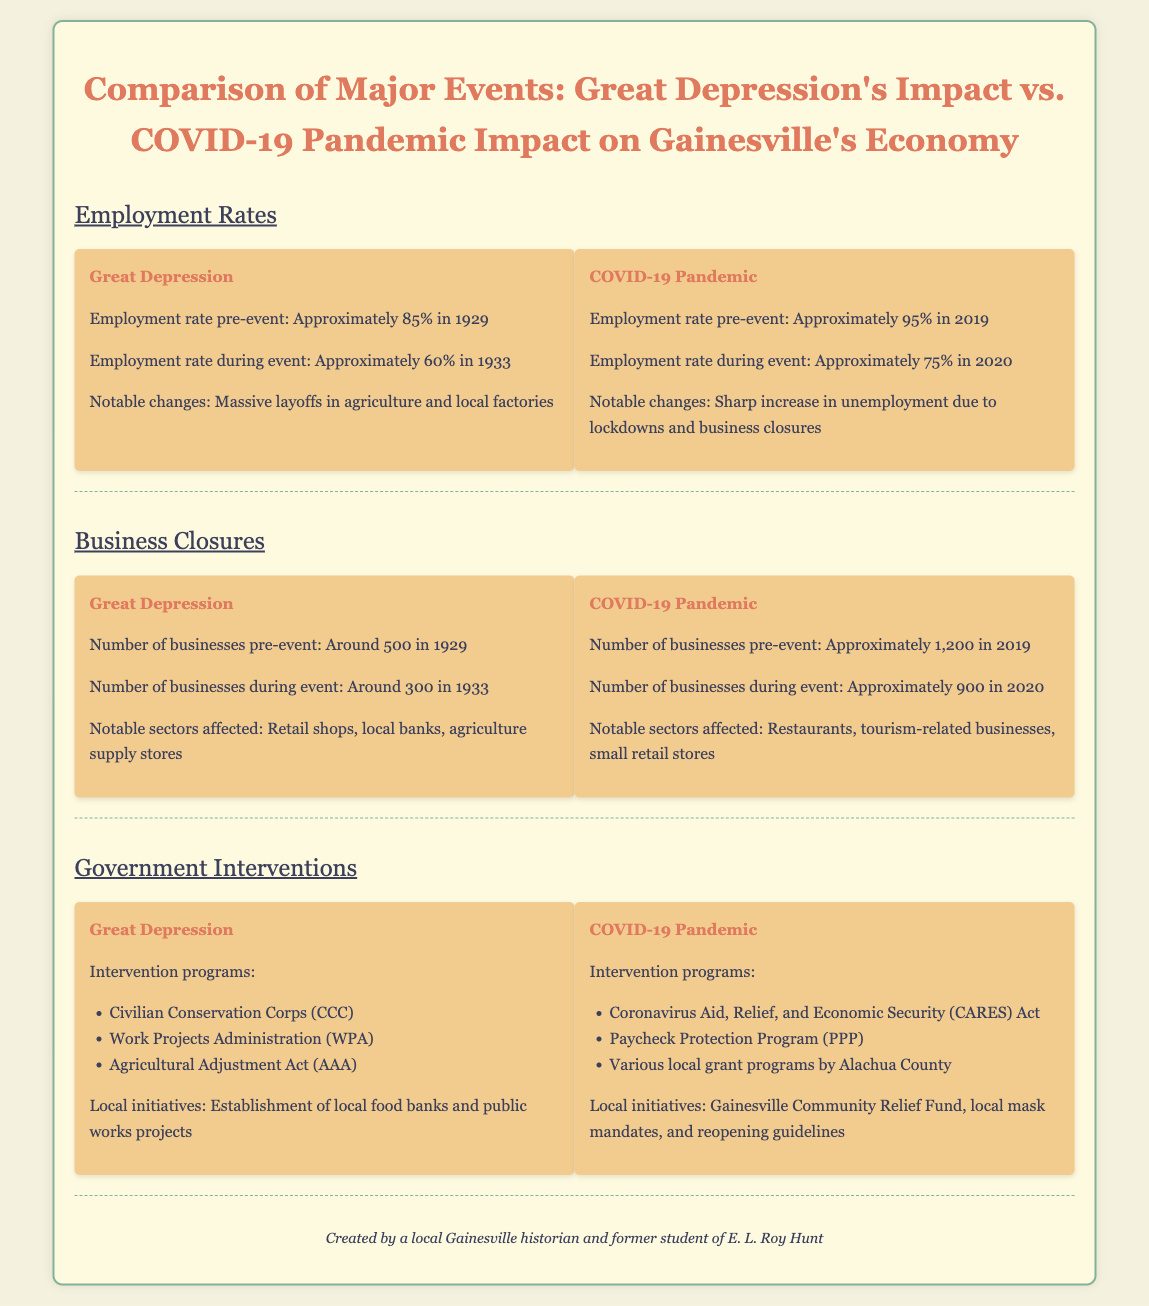what was the employment rate during the Great Depression? The employment rate during the Great Depression was approximately 60% in 1933.
Answer: 60% what was the number of businesses in Gainesville in 2019 before COVID-19? The number of businesses in Gainesville before COVID-19 was approximately 1,200 in 2019.
Answer: 1,200 what intervention program was established during the Great Depression? One of the intervention programs established during the Great Depression was the Civilian Conservation Corps (CCC).
Answer: Civilian Conservation Corps (CCC) how many businesses were there in Gainesville during the Great Depression? There were around 300 businesses in Gainesville during the Great Depression in 1933.
Answer: 300 what was the employment rate in Gainesville before the COVID-19 pandemic? The employment rate before the COVID-19 pandemic was approximately 95% in 2019.
Answer: 95% which sector was notably affected by business closures during COVID-19? A notably affected sector during COVID-19 was the restaurant sector.
Answer: Restaurants what year did the COVID-19 pandemic significantly impact employment rates? The COVID-19 pandemic significantly impacted employment rates in 2020.
Answer: 2020 what government intervention was part of the COVID-19 response? One of the government interventions during the COVID-19 response was the Coronavirus Aid, Relief, and Economic Security (CARES) Act.
Answer: Coronavirus Aid, Relief, and Economic Security (CARES) Act 